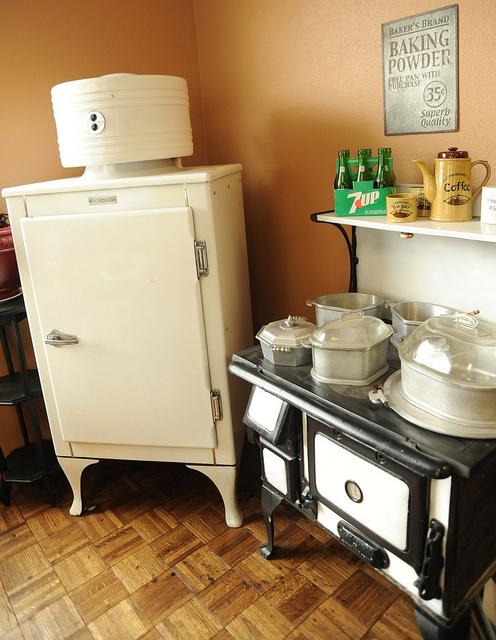What color are the room's walls?
Quick response, please. Tan. Are the beverages probably the most up-to-date items in this scene?
Quick response, please. Yes. What beverage is available?
Quick response, please. 7 up. 